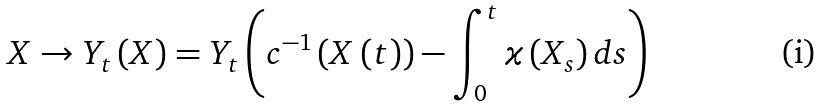<formula> <loc_0><loc_0><loc_500><loc_500>X \rightarrow Y _ { t } \left ( X \right ) = Y _ { t } \left ( c ^ { - 1 } \left ( X \left ( t \right ) \right ) - \int _ { 0 } ^ { t } \varkappa \left ( X _ { s } \right ) d s \right )</formula> 